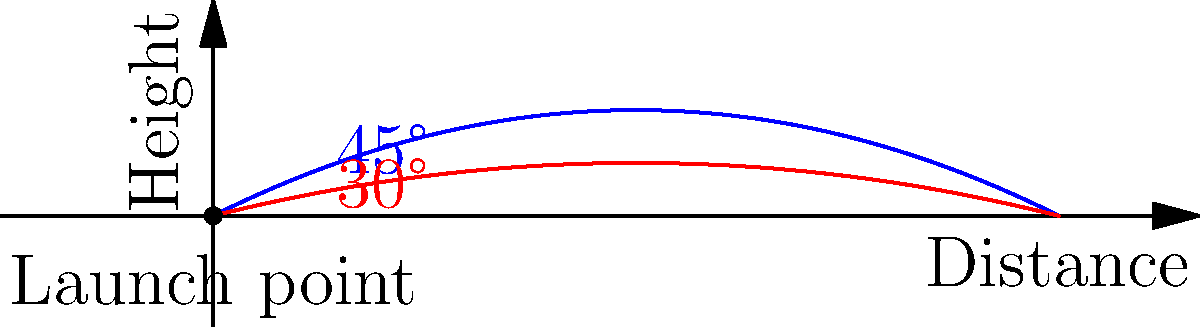As a disappointed long-standing supporter of the Sam Houston Bearkats football team, you've been analyzing the quarterback's throwing technique. Which launch angle should the quarterback aim for to achieve maximum distance when throwing a football, assuming no air resistance? To determine the optimal angle for maximum distance, we need to consider the principles of projectile motion:

1. In projectile motion without air resistance, the trajectory follows a parabolic path.

2. The range (R) of a projectile is given by the equation:
   $$R = \frac{v^2 \sin(2\theta)}{g}$$
   where $v$ is the initial velocity, $\theta$ is the launch angle, and $g$ is the acceleration due to gravity.

3. To maximize the range, we need to maximize $\sin(2\theta)$.

4. The maximum value of sine function is 1, which occurs when its argument is 90°.

5. So, we need $2\theta = 90°$, or $\theta = 45°$.

6. This result is independent of the initial velocity and the effects of gravity.

7. In the diagram, the blue trajectory represents a 45° launch angle, which reaches farther than the red trajectory representing a 30° launch angle.

Therefore, to achieve maximum distance, the quarterback should aim for a 45° launch angle.
Answer: 45° 